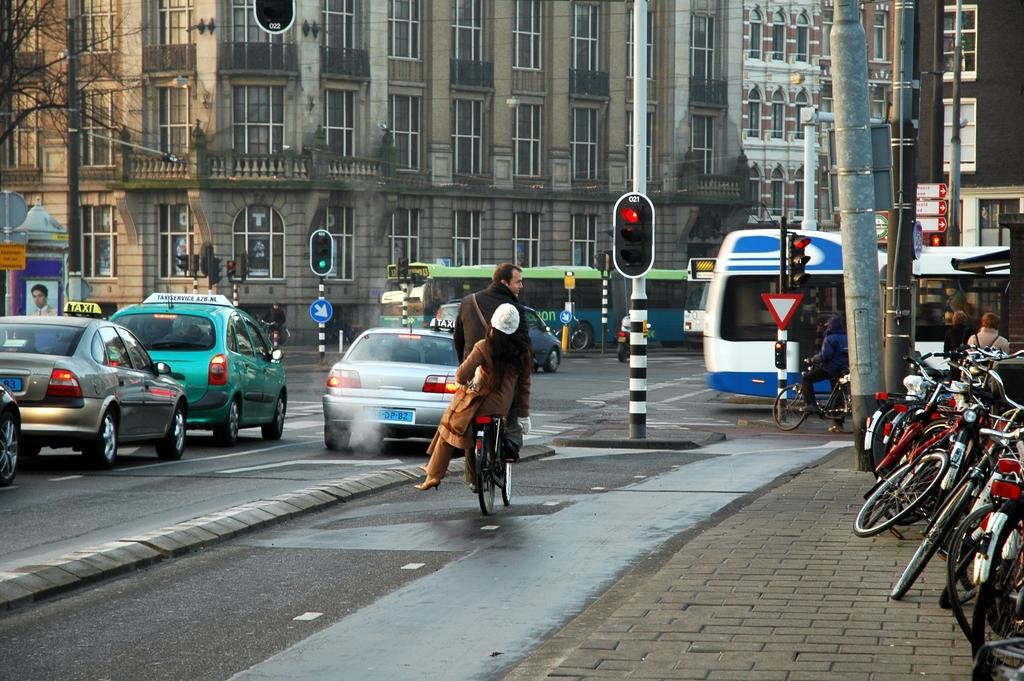Describe this image in one or two sentences. This is a street view ,In the middle there is a man he is riding bicycle on that bicycle there is a woman. In the middle there is a traffic signal light. On the left there are four cars. On the right there are many bicycles and tree. In the background there are some vehicles ,building and sign boards. 